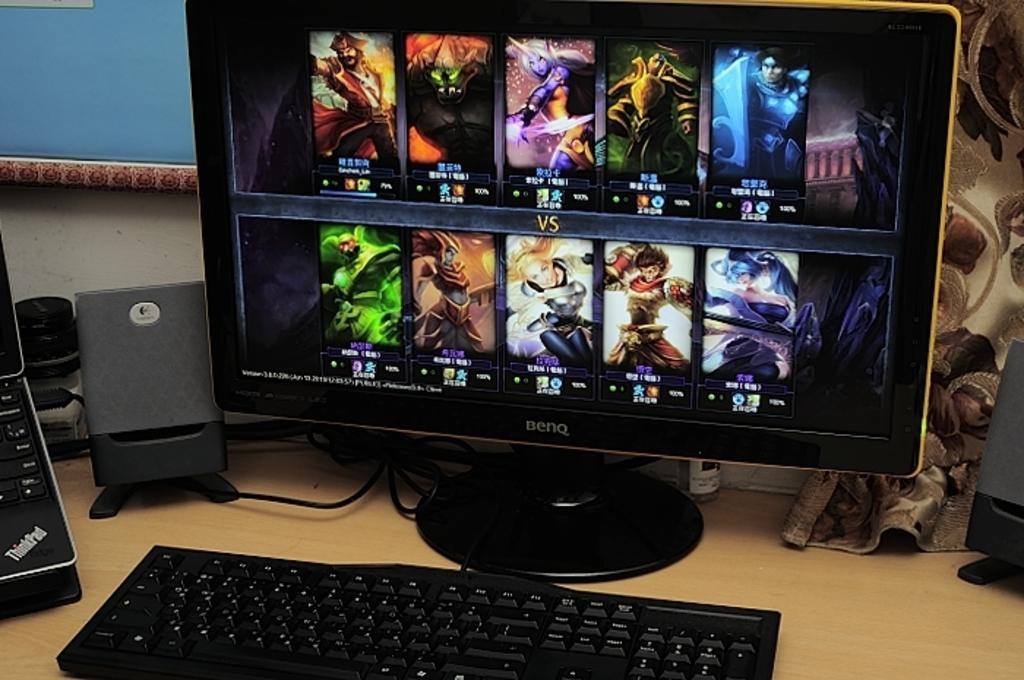<image>
Describe the image concisely. A thinkpad laptop sits open to the left of the computer. 